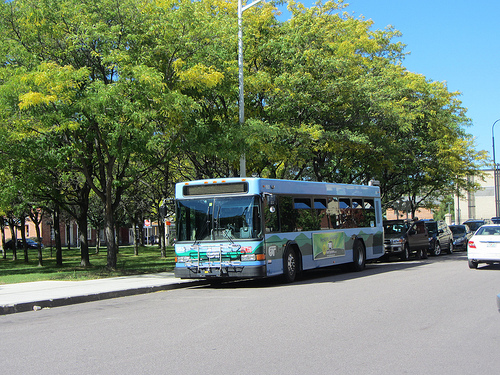What might be happening inside the bus? Inside the bus, passengers might be finding their seats, reading books or newspapers, checking their phones, or chatting with one another. Perhaps a few students are discussing their school projects, while some elderly passengers look out the window, reminiscing about the days gone by. The bus driver could be focused on the road ahead, ensuring a safe and smooth journey for all on board. Could the bus have a unique story or history? Yes, buses often have unique stories or histories. This particular bus might have been part of the city’s fleet for years, witnessing countless everyday stories unfold through its windows. It may have seen the city change and grow, from building renovations to new trees being planted. Perhaps this bus has been a part of important events like parades, community celebrations, or has even transported participants and spectators to significant occasions, becoming an unspoken part of the city's living history. 